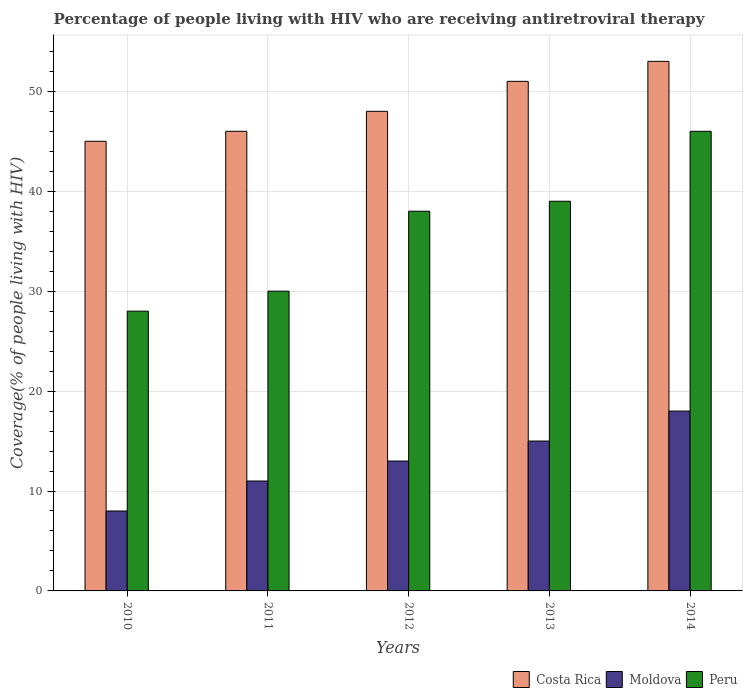How many different coloured bars are there?
Offer a very short reply. 3. How many groups of bars are there?
Provide a short and direct response. 5. Are the number of bars on each tick of the X-axis equal?
Provide a short and direct response. Yes. How many bars are there on the 5th tick from the right?
Provide a short and direct response. 3. What is the label of the 5th group of bars from the left?
Keep it short and to the point. 2014. In how many cases, is the number of bars for a given year not equal to the number of legend labels?
Your answer should be compact. 0. What is the percentage of the HIV infected people who are receiving antiretroviral therapy in Peru in 2010?
Offer a very short reply. 28. Across all years, what is the maximum percentage of the HIV infected people who are receiving antiretroviral therapy in Costa Rica?
Make the answer very short. 53. Across all years, what is the minimum percentage of the HIV infected people who are receiving antiretroviral therapy in Moldova?
Your answer should be compact. 8. In which year was the percentage of the HIV infected people who are receiving antiretroviral therapy in Costa Rica minimum?
Your answer should be compact. 2010. What is the total percentage of the HIV infected people who are receiving antiretroviral therapy in Peru in the graph?
Offer a very short reply. 181. What is the difference between the percentage of the HIV infected people who are receiving antiretroviral therapy in Costa Rica in 2010 and that in 2012?
Ensure brevity in your answer.  -3. What is the difference between the percentage of the HIV infected people who are receiving antiretroviral therapy in Peru in 2010 and the percentage of the HIV infected people who are receiving antiretroviral therapy in Costa Rica in 2013?
Provide a succinct answer. -23. What is the average percentage of the HIV infected people who are receiving antiretroviral therapy in Costa Rica per year?
Offer a terse response. 48.6. In the year 2013, what is the difference between the percentage of the HIV infected people who are receiving antiretroviral therapy in Costa Rica and percentage of the HIV infected people who are receiving antiretroviral therapy in Moldova?
Provide a succinct answer. 36. What is the ratio of the percentage of the HIV infected people who are receiving antiretroviral therapy in Costa Rica in 2012 to that in 2014?
Provide a short and direct response. 0.91. Is the difference between the percentage of the HIV infected people who are receiving antiretroviral therapy in Costa Rica in 2010 and 2011 greater than the difference between the percentage of the HIV infected people who are receiving antiretroviral therapy in Moldova in 2010 and 2011?
Keep it short and to the point. Yes. What is the difference between the highest and the lowest percentage of the HIV infected people who are receiving antiretroviral therapy in Peru?
Your answer should be very brief. 18. Is the sum of the percentage of the HIV infected people who are receiving antiretroviral therapy in Peru in 2010 and 2014 greater than the maximum percentage of the HIV infected people who are receiving antiretroviral therapy in Moldova across all years?
Provide a short and direct response. Yes. What does the 1st bar from the left in 2010 represents?
Make the answer very short. Costa Rica. Is it the case that in every year, the sum of the percentage of the HIV infected people who are receiving antiretroviral therapy in Moldova and percentage of the HIV infected people who are receiving antiretroviral therapy in Peru is greater than the percentage of the HIV infected people who are receiving antiretroviral therapy in Costa Rica?
Offer a very short reply. No. How many bars are there?
Your response must be concise. 15. Does the graph contain any zero values?
Offer a very short reply. No. Does the graph contain grids?
Provide a succinct answer. Yes. Where does the legend appear in the graph?
Your response must be concise. Bottom right. What is the title of the graph?
Make the answer very short. Percentage of people living with HIV who are receiving antiretroviral therapy. What is the label or title of the X-axis?
Offer a very short reply. Years. What is the label or title of the Y-axis?
Ensure brevity in your answer.  Coverage(% of people living with HIV). What is the Coverage(% of people living with HIV) in Costa Rica in 2010?
Your response must be concise. 45. What is the Coverage(% of people living with HIV) of Peru in 2010?
Your answer should be compact. 28. What is the Coverage(% of people living with HIV) in Moldova in 2011?
Give a very brief answer. 11. What is the Coverage(% of people living with HIV) in Costa Rica in 2012?
Keep it short and to the point. 48. What is the Coverage(% of people living with HIV) of Peru in 2012?
Make the answer very short. 38. What is the Coverage(% of people living with HIV) of Costa Rica in 2013?
Make the answer very short. 51. What is the Coverage(% of people living with HIV) of Moldova in 2013?
Your answer should be very brief. 15. What is the Coverage(% of people living with HIV) in Peru in 2014?
Give a very brief answer. 46. Across all years, what is the maximum Coverage(% of people living with HIV) in Costa Rica?
Your answer should be very brief. 53. Across all years, what is the maximum Coverage(% of people living with HIV) in Peru?
Provide a short and direct response. 46. Across all years, what is the minimum Coverage(% of people living with HIV) of Costa Rica?
Give a very brief answer. 45. What is the total Coverage(% of people living with HIV) in Costa Rica in the graph?
Your answer should be very brief. 243. What is the total Coverage(% of people living with HIV) in Peru in the graph?
Your response must be concise. 181. What is the difference between the Coverage(% of people living with HIV) of Moldova in 2010 and that in 2014?
Give a very brief answer. -10. What is the difference between the Coverage(% of people living with HIV) of Costa Rica in 2011 and that in 2012?
Offer a very short reply. -2. What is the difference between the Coverage(% of people living with HIV) of Moldova in 2011 and that in 2012?
Your response must be concise. -2. What is the difference between the Coverage(% of people living with HIV) of Peru in 2011 and that in 2012?
Your answer should be compact. -8. What is the difference between the Coverage(% of people living with HIV) of Costa Rica in 2011 and that in 2013?
Ensure brevity in your answer.  -5. What is the difference between the Coverage(% of people living with HIV) in Peru in 2011 and that in 2013?
Offer a terse response. -9. What is the difference between the Coverage(% of people living with HIV) in Costa Rica in 2011 and that in 2014?
Give a very brief answer. -7. What is the difference between the Coverage(% of people living with HIV) of Moldova in 2011 and that in 2014?
Keep it short and to the point. -7. What is the difference between the Coverage(% of people living with HIV) in Moldova in 2012 and that in 2013?
Your response must be concise. -2. What is the difference between the Coverage(% of people living with HIV) of Costa Rica in 2012 and that in 2014?
Provide a succinct answer. -5. What is the difference between the Coverage(% of people living with HIV) in Costa Rica in 2013 and that in 2014?
Your answer should be very brief. -2. What is the difference between the Coverage(% of people living with HIV) in Costa Rica in 2010 and the Coverage(% of people living with HIV) in Moldova in 2011?
Give a very brief answer. 34. What is the difference between the Coverage(% of people living with HIV) of Costa Rica in 2010 and the Coverage(% of people living with HIV) of Peru in 2012?
Provide a short and direct response. 7. What is the difference between the Coverage(% of people living with HIV) in Moldova in 2010 and the Coverage(% of people living with HIV) in Peru in 2012?
Make the answer very short. -30. What is the difference between the Coverage(% of people living with HIV) in Moldova in 2010 and the Coverage(% of people living with HIV) in Peru in 2013?
Offer a very short reply. -31. What is the difference between the Coverage(% of people living with HIV) in Costa Rica in 2010 and the Coverage(% of people living with HIV) in Moldova in 2014?
Your answer should be compact. 27. What is the difference between the Coverage(% of people living with HIV) in Moldova in 2010 and the Coverage(% of people living with HIV) in Peru in 2014?
Offer a terse response. -38. What is the difference between the Coverage(% of people living with HIV) in Costa Rica in 2011 and the Coverage(% of people living with HIV) in Moldova in 2013?
Your response must be concise. 31. What is the difference between the Coverage(% of people living with HIV) in Costa Rica in 2011 and the Coverage(% of people living with HIV) in Peru in 2013?
Give a very brief answer. 7. What is the difference between the Coverage(% of people living with HIV) in Moldova in 2011 and the Coverage(% of people living with HIV) in Peru in 2013?
Provide a succinct answer. -28. What is the difference between the Coverage(% of people living with HIV) in Moldova in 2011 and the Coverage(% of people living with HIV) in Peru in 2014?
Provide a succinct answer. -35. What is the difference between the Coverage(% of people living with HIV) of Costa Rica in 2012 and the Coverage(% of people living with HIV) of Moldova in 2013?
Your response must be concise. 33. What is the difference between the Coverage(% of people living with HIV) in Costa Rica in 2012 and the Coverage(% of people living with HIV) in Peru in 2013?
Provide a succinct answer. 9. What is the difference between the Coverage(% of people living with HIV) in Costa Rica in 2012 and the Coverage(% of people living with HIV) in Peru in 2014?
Make the answer very short. 2. What is the difference between the Coverage(% of people living with HIV) of Moldova in 2012 and the Coverage(% of people living with HIV) of Peru in 2014?
Keep it short and to the point. -33. What is the difference between the Coverage(% of people living with HIV) in Costa Rica in 2013 and the Coverage(% of people living with HIV) in Peru in 2014?
Your answer should be very brief. 5. What is the difference between the Coverage(% of people living with HIV) of Moldova in 2013 and the Coverage(% of people living with HIV) of Peru in 2014?
Keep it short and to the point. -31. What is the average Coverage(% of people living with HIV) in Costa Rica per year?
Provide a succinct answer. 48.6. What is the average Coverage(% of people living with HIV) of Peru per year?
Ensure brevity in your answer.  36.2. In the year 2010, what is the difference between the Coverage(% of people living with HIV) in Costa Rica and Coverage(% of people living with HIV) in Peru?
Offer a terse response. 17. In the year 2010, what is the difference between the Coverage(% of people living with HIV) in Moldova and Coverage(% of people living with HIV) in Peru?
Give a very brief answer. -20. In the year 2011, what is the difference between the Coverage(% of people living with HIV) in Moldova and Coverage(% of people living with HIV) in Peru?
Keep it short and to the point. -19. In the year 2012, what is the difference between the Coverage(% of people living with HIV) of Costa Rica and Coverage(% of people living with HIV) of Moldova?
Ensure brevity in your answer.  35. In the year 2013, what is the difference between the Coverage(% of people living with HIV) in Costa Rica and Coverage(% of people living with HIV) in Moldova?
Offer a terse response. 36. In the year 2013, what is the difference between the Coverage(% of people living with HIV) of Moldova and Coverage(% of people living with HIV) of Peru?
Give a very brief answer. -24. In the year 2014, what is the difference between the Coverage(% of people living with HIV) of Costa Rica and Coverage(% of people living with HIV) of Peru?
Give a very brief answer. 7. What is the ratio of the Coverage(% of people living with HIV) in Costa Rica in 2010 to that in 2011?
Keep it short and to the point. 0.98. What is the ratio of the Coverage(% of people living with HIV) of Moldova in 2010 to that in 2011?
Provide a succinct answer. 0.73. What is the ratio of the Coverage(% of people living with HIV) in Peru in 2010 to that in 2011?
Your response must be concise. 0.93. What is the ratio of the Coverage(% of people living with HIV) of Moldova in 2010 to that in 2012?
Your response must be concise. 0.62. What is the ratio of the Coverage(% of people living with HIV) in Peru in 2010 to that in 2012?
Keep it short and to the point. 0.74. What is the ratio of the Coverage(% of people living with HIV) of Costa Rica in 2010 to that in 2013?
Give a very brief answer. 0.88. What is the ratio of the Coverage(% of people living with HIV) in Moldova in 2010 to that in 2013?
Your response must be concise. 0.53. What is the ratio of the Coverage(% of people living with HIV) of Peru in 2010 to that in 2013?
Your answer should be very brief. 0.72. What is the ratio of the Coverage(% of people living with HIV) of Costa Rica in 2010 to that in 2014?
Offer a terse response. 0.85. What is the ratio of the Coverage(% of people living with HIV) of Moldova in 2010 to that in 2014?
Provide a short and direct response. 0.44. What is the ratio of the Coverage(% of people living with HIV) of Peru in 2010 to that in 2014?
Make the answer very short. 0.61. What is the ratio of the Coverage(% of people living with HIV) in Costa Rica in 2011 to that in 2012?
Keep it short and to the point. 0.96. What is the ratio of the Coverage(% of people living with HIV) of Moldova in 2011 to that in 2012?
Keep it short and to the point. 0.85. What is the ratio of the Coverage(% of people living with HIV) of Peru in 2011 to that in 2012?
Keep it short and to the point. 0.79. What is the ratio of the Coverage(% of people living with HIV) in Costa Rica in 2011 to that in 2013?
Ensure brevity in your answer.  0.9. What is the ratio of the Coverage(% of people living with HIV) of Moldova in 2011 to that in 2013?
Keep it short and to the point. 0.73. What is the ratio of the Coverage(% of people living with HIV) of Peru in 2011 to that in 2013?
Offer a very short reply. 0.77. What is the ratio of the Coverage(% of people living with HIV) of Costa Rica in 2011 to that in 2014?
Offer a very short reply. 0.87. What is the ratio of the Coverage(% of people living with HIV) of Moldova in 2011 to that in 2014?
Provide a succinct answer. 0.61. What is the ratio of the Coverage(% of people living with HIV) of Peru in 2011 to that in 2014?
Your answer should be very brief. 0.65. What is the ratio of the Coverage(% of people living with HIV) in Costa Rica in 2012 to that in 2013?
Offer a terse response. 0.94. What is the ratio of the Coverage(% of people living with HIV) of Moldova in 2012 to that in 2013?
Your answer should be very brief. 0.87. What is the ratio of the Coverage(% of people living with HIV) of Peru in 2012 to that in 2013?
Offer a very short reply. 0.97. What is the ratio of the Coverage(% of people living with HIV) in Costa Rica in 2012 to that in 2014?
Ensure brevity in your answer.  0.91. What is the ratio of the Coverage(% of people living with HIV) in Moldova in 2012 to that in 2014?
Your answer should be very brief. 0.72. What is the ratio of the Coverage(% of people living with HIV) of Peru in 2012 to that in 2014?
Make the answer very short. 0.83. What is the ratio of the Coverage(% of people living with HIV) of Costa Rica in 2013 to that in 2014?
Keep it short and to the point. 0.96. What is the ratio of the Coverage(% of people living with HIV) of Moldova in 2013 to that in 2014?
Provide a succinct answer. 0.83. What is the ratio of the Coverage(% of people living with HIV) in Peru in 2013 to that in 2014?
Ensure brevity in your answer.  0.85. What is the difference between the highest and the second highest Coverage(% of people living with HIV) in Costa Rica?
Make the answer very short. 2. What is the difference between the highest and the second highest Coverage(% of people living with HIV) of Moldova?
Give a very brief answer. 3. What is the difference between the highest and the second highest Coverage(% of people living with HIV) in Peru?
Keep it short and to the point. 7. What is the difference between the highest and the lowest Coverage(% of people living with HIV) of Costa Rica?
Provide a succinct answer. 8. What is the difference between the highest and the lowest Coverage(% of people living with HIV) in Moldova?
Ensure brevity in your answer.  10. What is the difference between the highest and the lowest Coverage(% of people living with HIV) in Peru?
Ensure brevity in your answer.  18. 